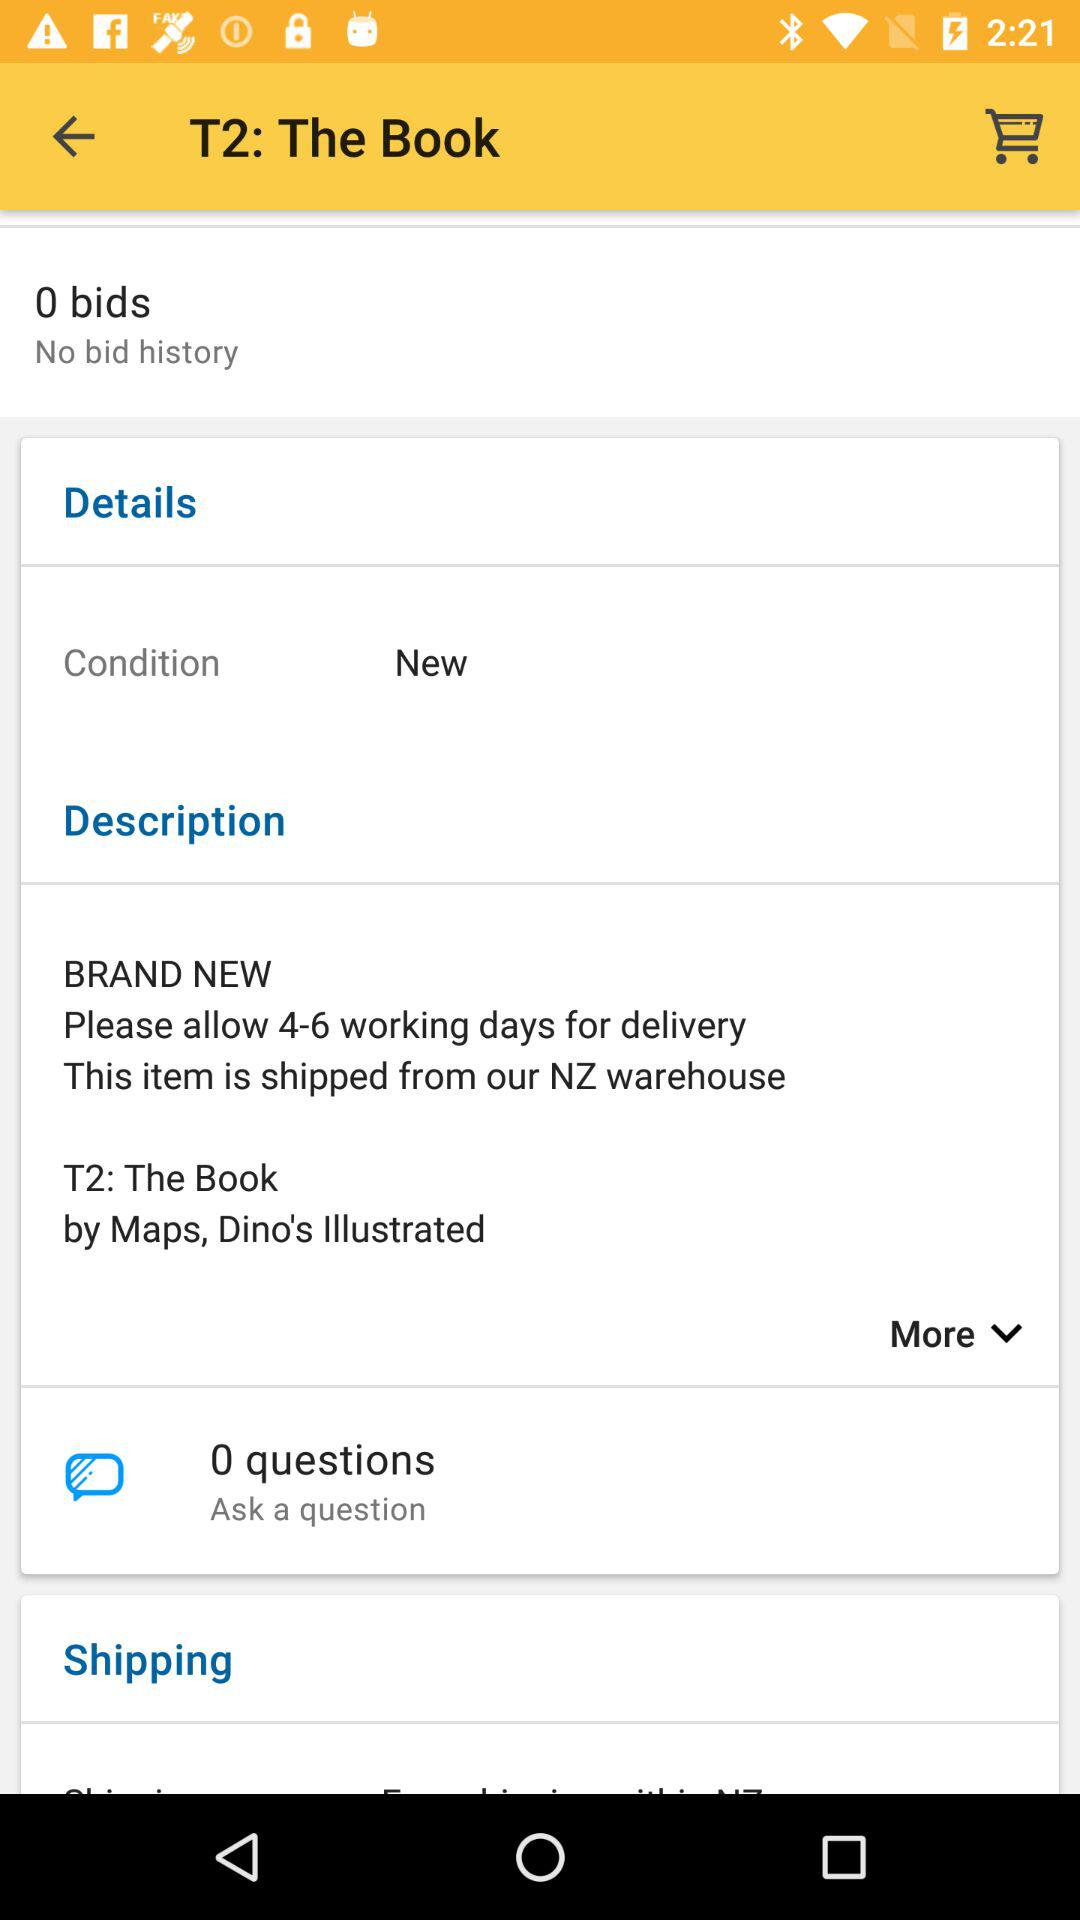Which shipping options are available?
When the provided information is insufficient, respond with <no answer>. <no answer> 